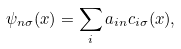Convert formula to latex. <formula><loc_0><loc_0><loc_500><loc_500>\psi _ { n \sigma } ( x ) = \sum _ { i } a _ { i n } c _ { i \sigma } ( x ) ,</formula> 